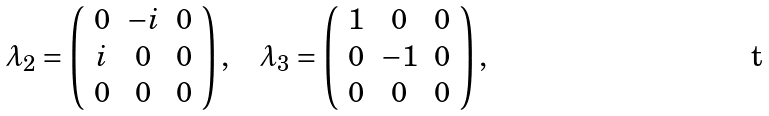<formula> <loc_0><loc_0><loc_500><loc_500>\lambda _ { 2 } = \left ( \begin{array} { c c c } 0 & - i & 0 \\ i & 0 & 0 \\ 0 & 0 & 0 \end{array} \right ) , & \quad \lambda _ { 3 } = \left ( \begin{array} { c c c } 1 & 0 & 0 \\ 0 & - 1 & 0 \\ 0 & 0 & 0 \end{array} \right ) ,</formula> 